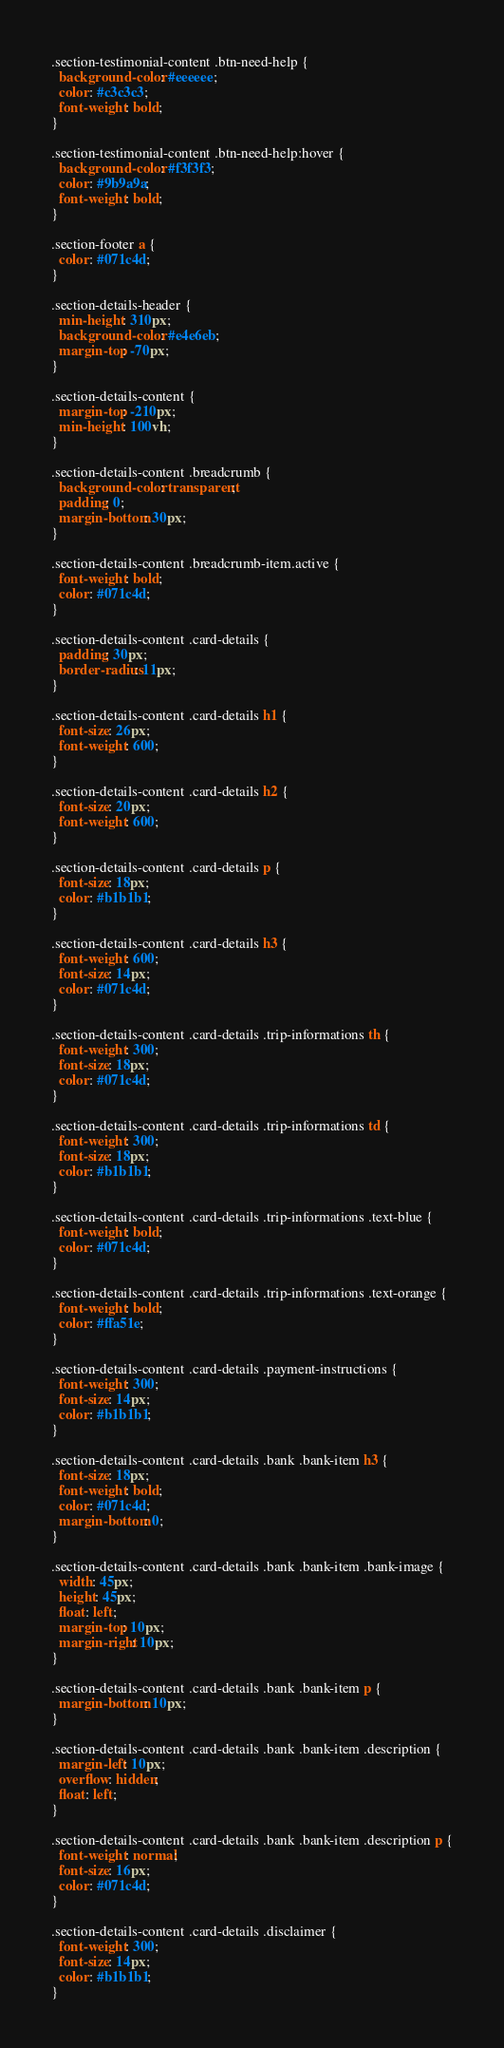Convert code to text. <code><loc_0><loc_0><loc_500><loc_500><_CSS_>.section-testimonial-content .btn-need-help {
  background-color: #eeeeee;
  color: #c3c3c3;
  font-weight: bold;
}

.section-testimonial-content .btn-need-help:hover {
  background-color: #f3f3f3;
  color: #9b9a9a;
  font-weight: bold;
}

.section-footer a {
  color: #071c4d;
}

.section-details-header {
  min-height: 310px;
  background-color: #e4e6eb;
  margin-top: -70px;
}

.section-details-content {
  margin-top: -210px;
  min-height: 100vh;
}

.section-details-content .breadcrumb {
  background-color: transparent;
  padding: 0;
  margin-bottom: 30px;
}

.section-details-content .breadcrumb-item.active {
  font-weight: bold;
  color: #071c4d;
}

.section-details-content .card-details {
  padding: 30px;
  border-radius: 11px;
}

.section-details-content .card-details h1 {
  font-size: 26px;
  font-weight: 600;
}

.section-details-content .card-details h2 {
  font-size: 20px;
  font-weight: 600;
}

.section-details-content .card-details p {
  font-size: 18px;
  color: #b1b1b1;
}

.section-details-content .card-details h3 {
  font-weight: 600;
  font-size: 14px;
  color: #071c4d;
}

.section-details-content .card-details .trip-informations th {
  font-weight: 300;
  font-size: 18px;
  color: #071c4d;
}

.section-details-content .card-details .trip-informations td {
  font-weight: 300;
  font-size: 18px;
  color: #b1b1b1;
}

.section-details-content .card-details .trip-informations .text-blue {
  font-weight: bold;
  color: #071c4d;
}

.section-details-content .card-details .trip-informations .text-orange {
  font-weight: bold;
  color: #ffa51e;
}

.section-details-content .card-details .payment-instructions {
  font-weight: 300;
  font-size: 14px;
  color: #b1b1b1;
}

.section-details-content .card-details .bank .bank-item h3 {
  font-size: 18px;
  font-weight: bold;
  color: #071c4d;
  margin-bottom: 0;
}

.section-details-content .card-details .bank .bank-item .bank-image {
  width: 45px;
  height: 45px;
  float: left;
  margin-top: 10px;
  margin-right: 10px;
}

.section-details-content .card-details .bank .bank-item p {
  margin-bottom: 10px;
}

.section-details-content .card-details .bank .bank-item .description {
  margin-left: 10px;
  overflow: hidden;
  float: left;
}

.section-details-content .card-details .bank .bank-item .description p {
  font-weight: normal;
  font-size: 16px;
  color: #071c4d;
}

.section-details-content .card-details .disclaimer {
  font-weight: 300;
  font-size: 14px;
  color: #b1b1b1;
}
</code> 